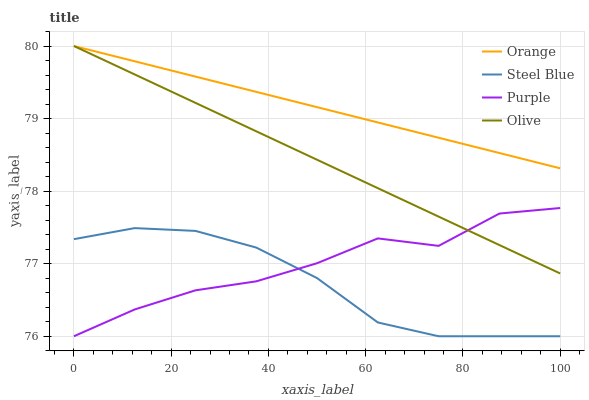Does Steel Blue have the minimum area under the curve?
Answer yes or no. Yes. Does Orange have the maximum area under the curve?
Answer yes or no. Yes. Does Purple have the minimum area under the curve?
Answer yes or no. No. Does Purple have the maximum area under the curve?
Answer yes or no. No. Is Orange the smoothest?
Answer yes or no. Yes. Is Purple the roughest?
Answer yes or no. Yes. Is Steel Blue the smoothest?
Answer yes or no. No. Is Steel Blue the roughest?
Answer yes or no. No. Does Purple have the lowest value?
Answer yes or no. Yes. Does Olive have the lowest value?
Answer yes or no. No. Does Olive have the highest value?
Answer yes or no. Yes. Does Purple have the highest value?
Answer yes or no. No. Is Steel Blue less than Orange?
Answer yes or no. Yes. Is Orange greater than Purple?
Answer yes or no. Yes. Does Steel Blue intersect Purple?
Answer yes or no. Yes. Is Steel Blue less than Purple?
Answer yes or no. No. Is Steel Blue greater than Purple?
Answer yes or no. No. Does Steel Blue intersect Orange?
Answer yes or no. No. 